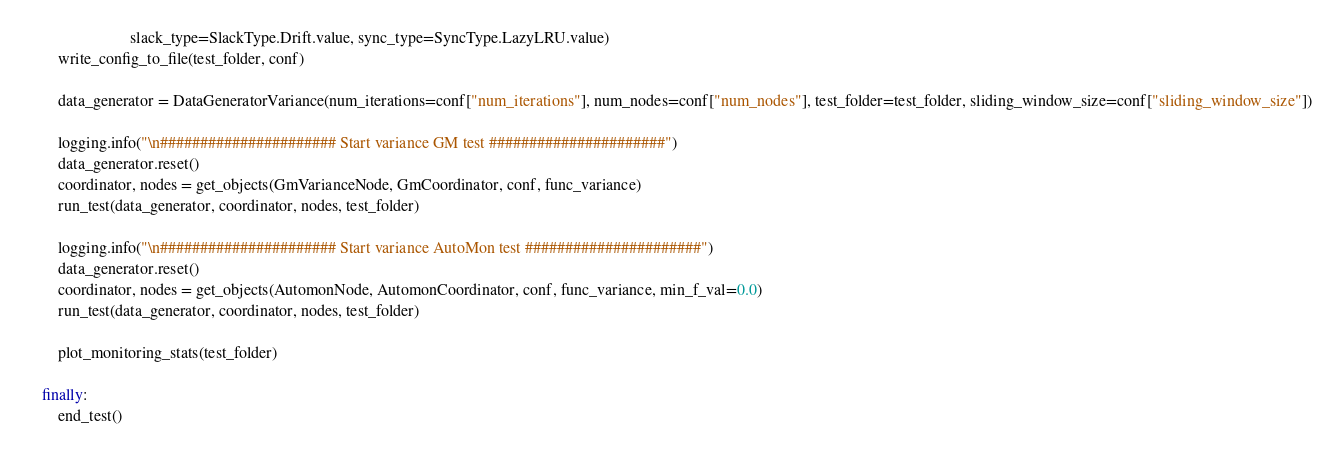Convert code to text. <code><loc_0><loc_0><loc_500><loc_500><_Python_>                          slack_type=SlackType.Drift.value, sync_type=SyncType.LazyLRU.value)
        write_config_to_file(test_folder, conf)

        data_generator = DataGeneratorVariance(num_iterations=conf["num_iterations"], num_nodes=conf["num_nodes"], test_folder=test_folder, sliding_window_size=conf["sliding_window_size"])

        logging.info("\n###################### Start variance GM test ######################")
        data_generator.reset()
        coordinator, nodes = get_objects(GmVarianceNode, GmCoordinator, conf, func_variance)
        run_test(data_generator, coordinator, nodes, test_folder)

        logging.info("\n###################### Start variance AutoMon test ######################")
        data_generator.reset()
        coordinator, nodes = get_objects(AutomonNode, AutomonCoordinator, conf, func_variance, min_f_val=0.0)
        run_test(data_generator, coordinator, nodes, test_folder)

        plot_monitoring_stats(test_folder)

    finally:
        end_test()
</code> 